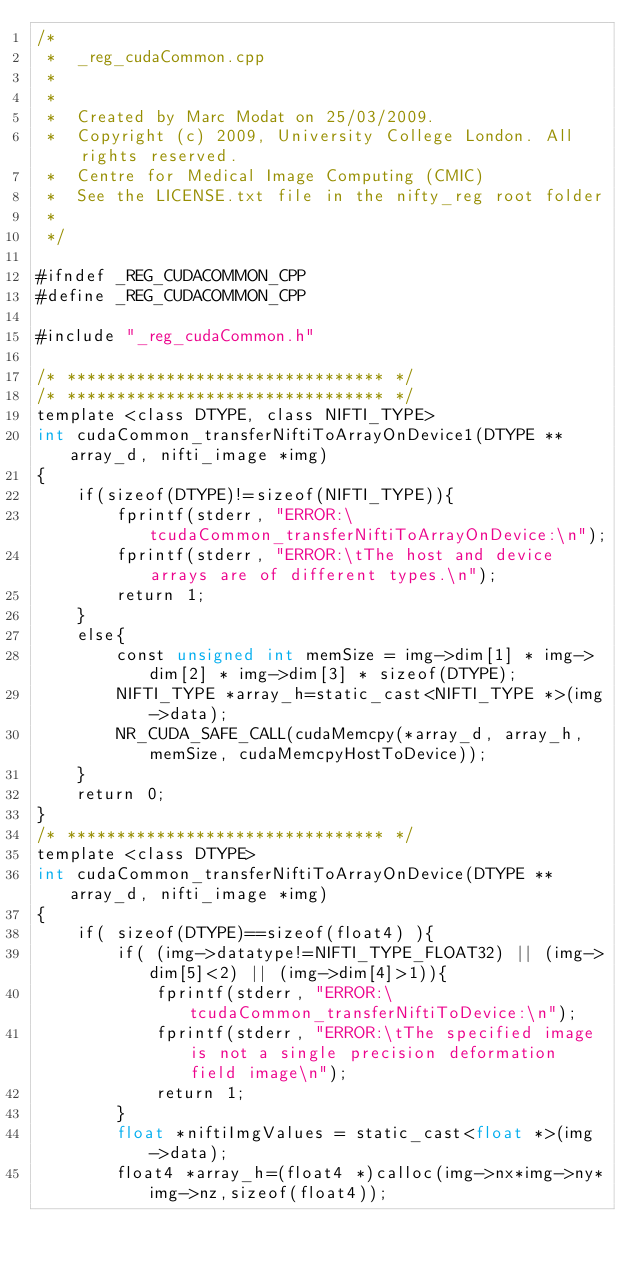<code> <loc_0><loc_0><loc_500><loc_500><_Cuda_>/*
 *  _reg_cudaCommon.cpp
 *  
 *
 *  Created by Marc Modat on 25/03/2009.
 *  Copyright (c) 2009, University College London. All rights reserved.
 *  Centre for Medical Image Computing (CMIC)
 *  See the LICENSE.txt file in the nifty_reg root folder
 *
 */

#ifndef _REG_CUDACOMMON_CPP
#define _REG_CUDACOMMON_CPP

#include "_reg_cudaCommon.h"

/* ******************************** */
/* ******************************** */
template <class DTYPE, class NIFTI_TYPE>
int cudaCommon_transferNiftiToArrayOnDevice1(DTYPE **array_d, nifti_image *img)
{
    if(sizeof(DTYPE)!=sizeof(NIFTI_TYPE)){
        fprintf(stderr, "ERROR:\tcudaCommon_transferNiftiToArrayOnDevice:\n");
        fprintf(stderr, "ERROR:\tThe host and device arrays are of different types.\n");
        return 1;
    }
    else{
        const unsigned int memSize = img->dim[1] * img->dim[2] * img->dim[3] * sizeof(DTYPE);
        NIFTI_TYPE *array_h=static_cast<NIFTI_TYPE *>(img->data);
        NR_CUDA_SAFE_CALL(cudaMemcpy(*array_d, array_h, memSize, cudaMemcpyHostToDevice));
    }
    return 0;
}
/* ******************************** */
template <class DTYPE>
int cudaCommon_transferNiftiToArrayOnDevice(DTYPE **array_d, nifti_image *img)
{
    if( sizeof(DTYPE)==sizeof(float4) ){
        if( (img->datatype!=NIFTI_TYPE_FLOAT32) || (img->dim[5]<2) || (img->dim[4]>1)){
            fprintf(stderr, "ERROR:\tcudaCommon_transferNiftiToDevice:\n");
            fprintf(stderr, "ERROR:\tThe specified image is not a single precision deformation field image\n");
            return 1;
        }
        float *niftiImgValues = static_cast<float *>(img->data);
        float4 *array_h=(float4 *)calloc(img->nx*img->ny*img->nz,sizeof(float4));</code> 